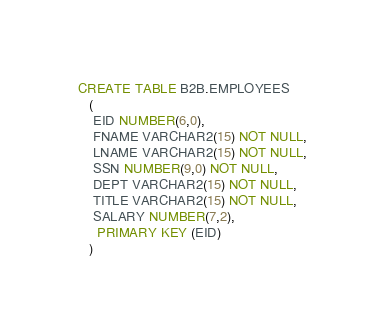Convert code to text. <code><loc_0><loc_0><loc_500><loc_500><_SQL_>CREATE TABLE B2B.EMPLOYEES 
   (	
    EID NUMBER(6,0), 
	FNAME VARCHAR2(15) NOT NULL, 
	LNAME VARCHAR2(15) NOT NULL, 
	SSN NUMBER(9,0) NOT NULL, 
	DEPT VARCHAR2(15) NOT NULL, 
	TITLE VARCHAR2(15) NOT NULL, 
	SALARY NUMBER(7,2), 
	 PRIMARY KEY (EID)
   )</code> 